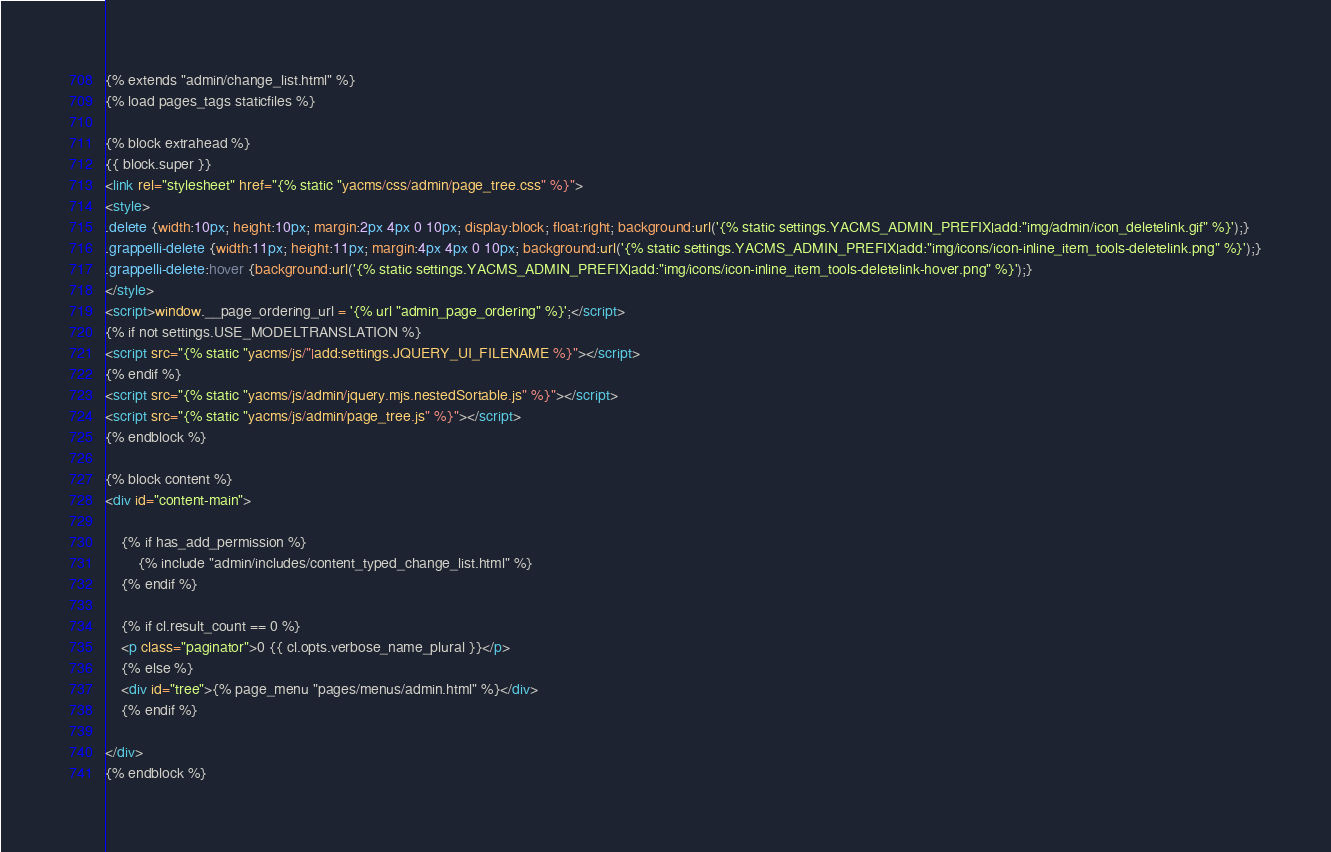<code> <loc_0><loc_0><loc_500><loc_500><_HTML_>{% extends "admin/change_list.html" %}
{% load pages_tags staticfiles %}

{% block extrahead %}
{{ block.super }}
<link rel="stylesheet" href="{% static "yacms/css/admin/page_tree.css" %}">
<style>
.delete {width:10px; height:10px; margin:2px 4px 0 10px; display:block; float:right; background:url('{% static settings.YACMS_ADMIN_PREFIX|add:"img/admin/icon_deletelink.gif" %}');}
.grappelli-delete {width:11px; height:11px; margin:4px 4px 0 10px; background:url('{% static settings.YACMS_ADMIN_PREFIX|add:"img/icons/icon-inline_item_tools-deletelink.png" %}');}
.grappelli-delete:hover {background:url('{% static settings.YACMS_ADMIN_PREFIX|add:"img/icons/icon-inline_item_tools-deletelink-hover.png" %}');}
</style>
<script>window.__page_ordering_url = '{% url "admin_page_ordering" %}';</script>
{% if not settings.USE_MODELTRANSLATION %}
<script src="{% static "yacms/js/"|add:settings.JQUERY_UI_FILENAME %}"></script>
{% endif %}
<script src="{% static "yacms/js/admin/jquery.mjs.nestedSortable.js" %}"></script>
<script src="{% static "yacms/js/admin/page_tree.js" %}"></script>
{% endblock %}

{% block content %}
<div id="content-main">

    {% if has_add_permission %}
        {% include "admin/includes/content_typed_change_list.html" %}
    {% endif %}

    {% if cl.result_count == 0 %}
    <p class="paginator">0 {{ cl.opts.verbose_name_plural }}</p>
    {% else %}
    <div id="tree">{% page_menu "pages/menus/admin.html" %}</div>
    {% endif %}

</div>
{% endblock %}
</code> 